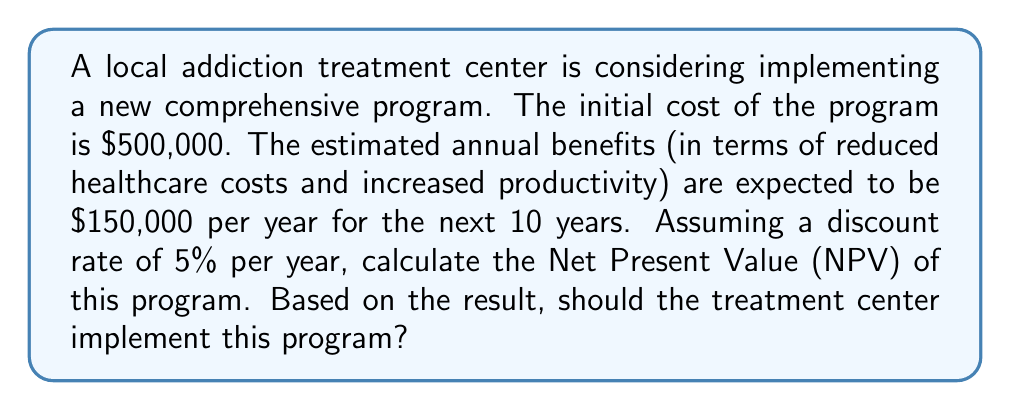Teach me how to tackle this problem. To solve this problem, we need to use the Net Present Value (NPV) formula:

$$ NPV = -C_0 + \sum_{t=1}^{n} \frac{C_t}{(1+r)^t} $$

Where:
$C_0$ = Initial investment
$C_t$ = Cash flow at time t
$r$ = Discount rate
$n$ = Number of periods

Given:
$C_0 = \$500,000$
$C_t = \$150,000$ per year for 10 years
$r = 5\% = 0.05$
$n = 10$ years

Let's calculate the present value of each year's benefit:

Year 1: $\frac{\$150,000}{(1+0.05)^1} = \$142,857.14$
Year 2: $\frac{\$150,000}{(1+0.05)^2} = \$136,054.42$
Year 3: $\frac{\$150,000}{(1+0.05)^3} = \$129,575.64$
...
Year 10: $\frac{\$150,000}{(1+0.05)^{10}} = \$92,096.56$

Sum of all present values:
$\$1,158,912.72$

Now, we can calculate the NPV:

$$ NPV = -\$500,000 + \$1,158,912.72 = \$658,912.72 $$

The positive NPV indicates that the program is financially beneficial. In the context of addiction treatment, this suggests that the long-term benefits of the program outweigh the initial costs, considering both the financial aspects and the potential improvement in patients' lives and societal outcomes.
Answer: The Net Present Value (NPV) of the addiction treatment program is $658,912.72. Since the NPV is positive, the treatment center should implement this program as it is expected to create value over the 10-year period, considering the time value of money. 